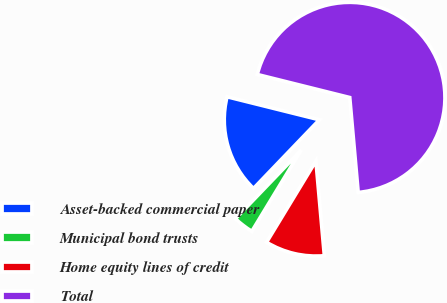Convert chart. <chart><loc_0><loc_0><loc_500><loc_500><pie_chart><fcel>Asset-backed commercial paper<fcel>Municipal bond trusts<fcel>Home equity lines of credit<fcel>Total<nl><fcel>16.72%<fcel>3.48%<fcel>10.1%<fcel>69.69%<nl></chart> 